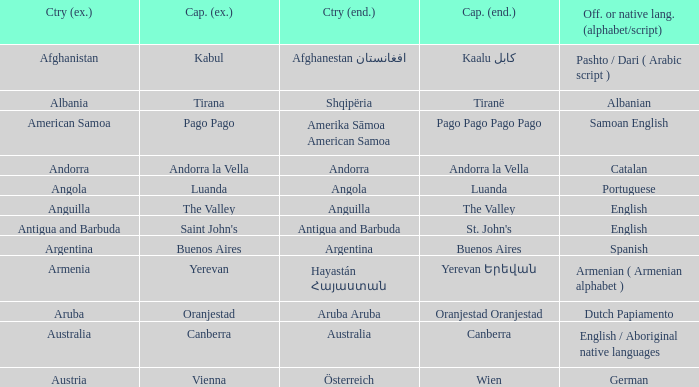What is the local name given to the city of Canberra? Canberra. 